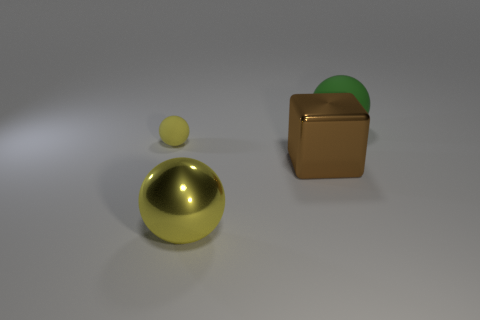Add 2 cubes. How many objects exist? 6 Subtract all spheres. How many objects are left? 1 Subtract 0 brown balls. How many objects are left? 4 Subtract all yellow matte objects. Subtract all yellow rubber balls. How many objects are left? 2 Add 3 big green matte spheres. How many big green matte spheres are left? 4 Add 1 large brown matte balls. How many large brown matte balls exist? 1 